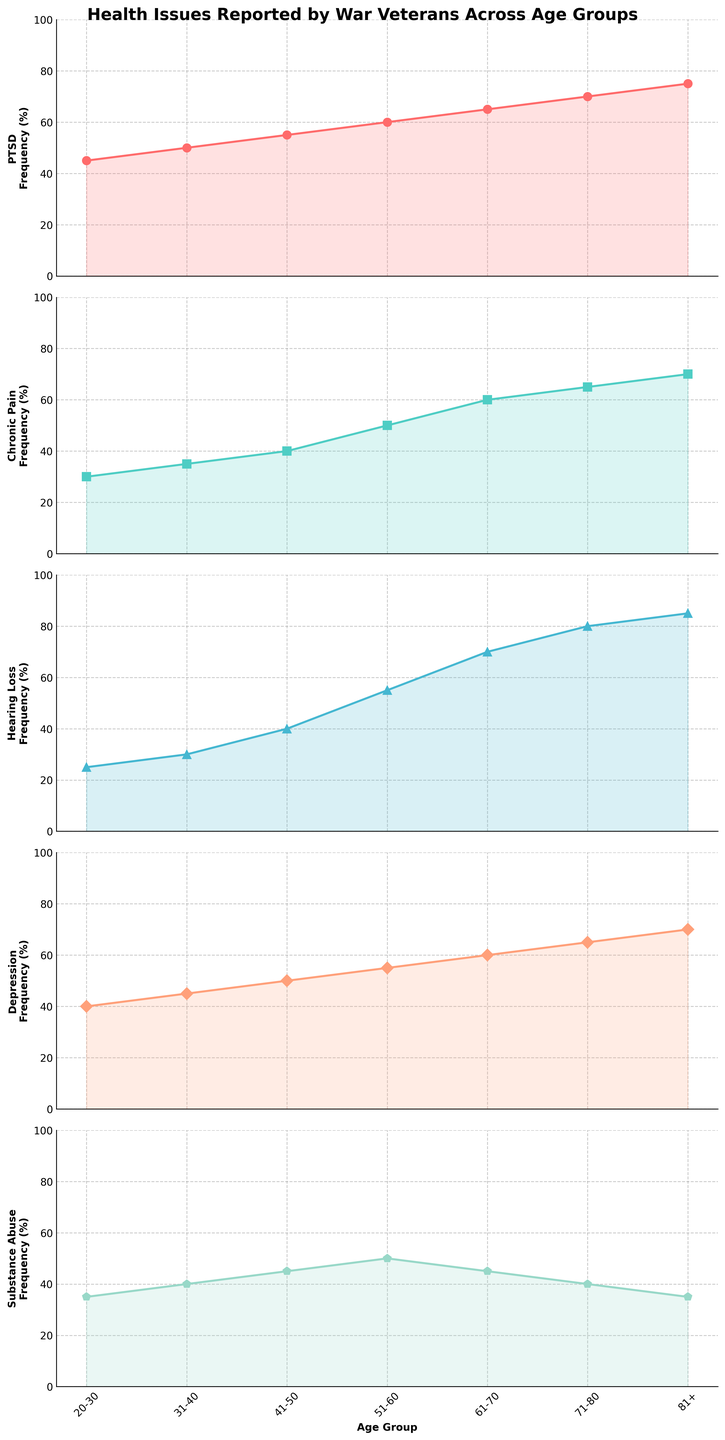What age group has the highest reported frequency of PTSD? Looking at the plot for PTSD, the 81+ age group has the highest frequency.
Answer: 81+ Between which two consecutive age groups is the largest increase in Chronic Pain reported? By comparing the difference between each pair of consecutive age groups in the Chronic Pain plot, the largest increase is between the 51-60 and 61-70 age groups.
Answer: 51-60 and 61-70 Which health issue decreases in frequency in the 81+ age group compared to 71-80? Among the issues, Substance Abuse shows a decrease when moving from the 71-80 to the 81+ age group.
Answer: Substance Abuse What is the average frequency of Hearing Loss reported in the 41-50 and 51-60 age groups? Adding the frequencies (40 and 55) and then dividing by 2, the average is calculated as (40 + 55) / 2 = 47.5.
Answer: 47.5 Between PTSD and Depression, which shows a more significant increase between the 20-30 and 31-40 age groups? The increase for PTSD is 50 - 45 = 5, whereas for Depression it is 45 - 40 = 5. Both have the same increase.
Answer: Equal Which health issue uses a green color in the plots? By identifying the colors used in the subplots, Chronic Pain is shown in green color.
Answer: Chronic Pain How many age groups report a Substance Abuse frequency of 45 or more? In the Substance Abuse plot, the 20-30, 31-40, 41-50, and 51-60 age groups all report frequencies of 45 or above, totaling 4 groups.
Answer: 4 What trend is observed in the frequency of Hearing Loss with increasing age groups? The plot for Hearing Loss shows a consistent increase in frequency as the age groups increase.
Answer: Increasing What is the sum of the frequencies of Depression reported in the 20-30 and 71-80 age groups? Adding the frequencies (40 and 65), the sum is 40 + 65 = 105.
Answer: 105 